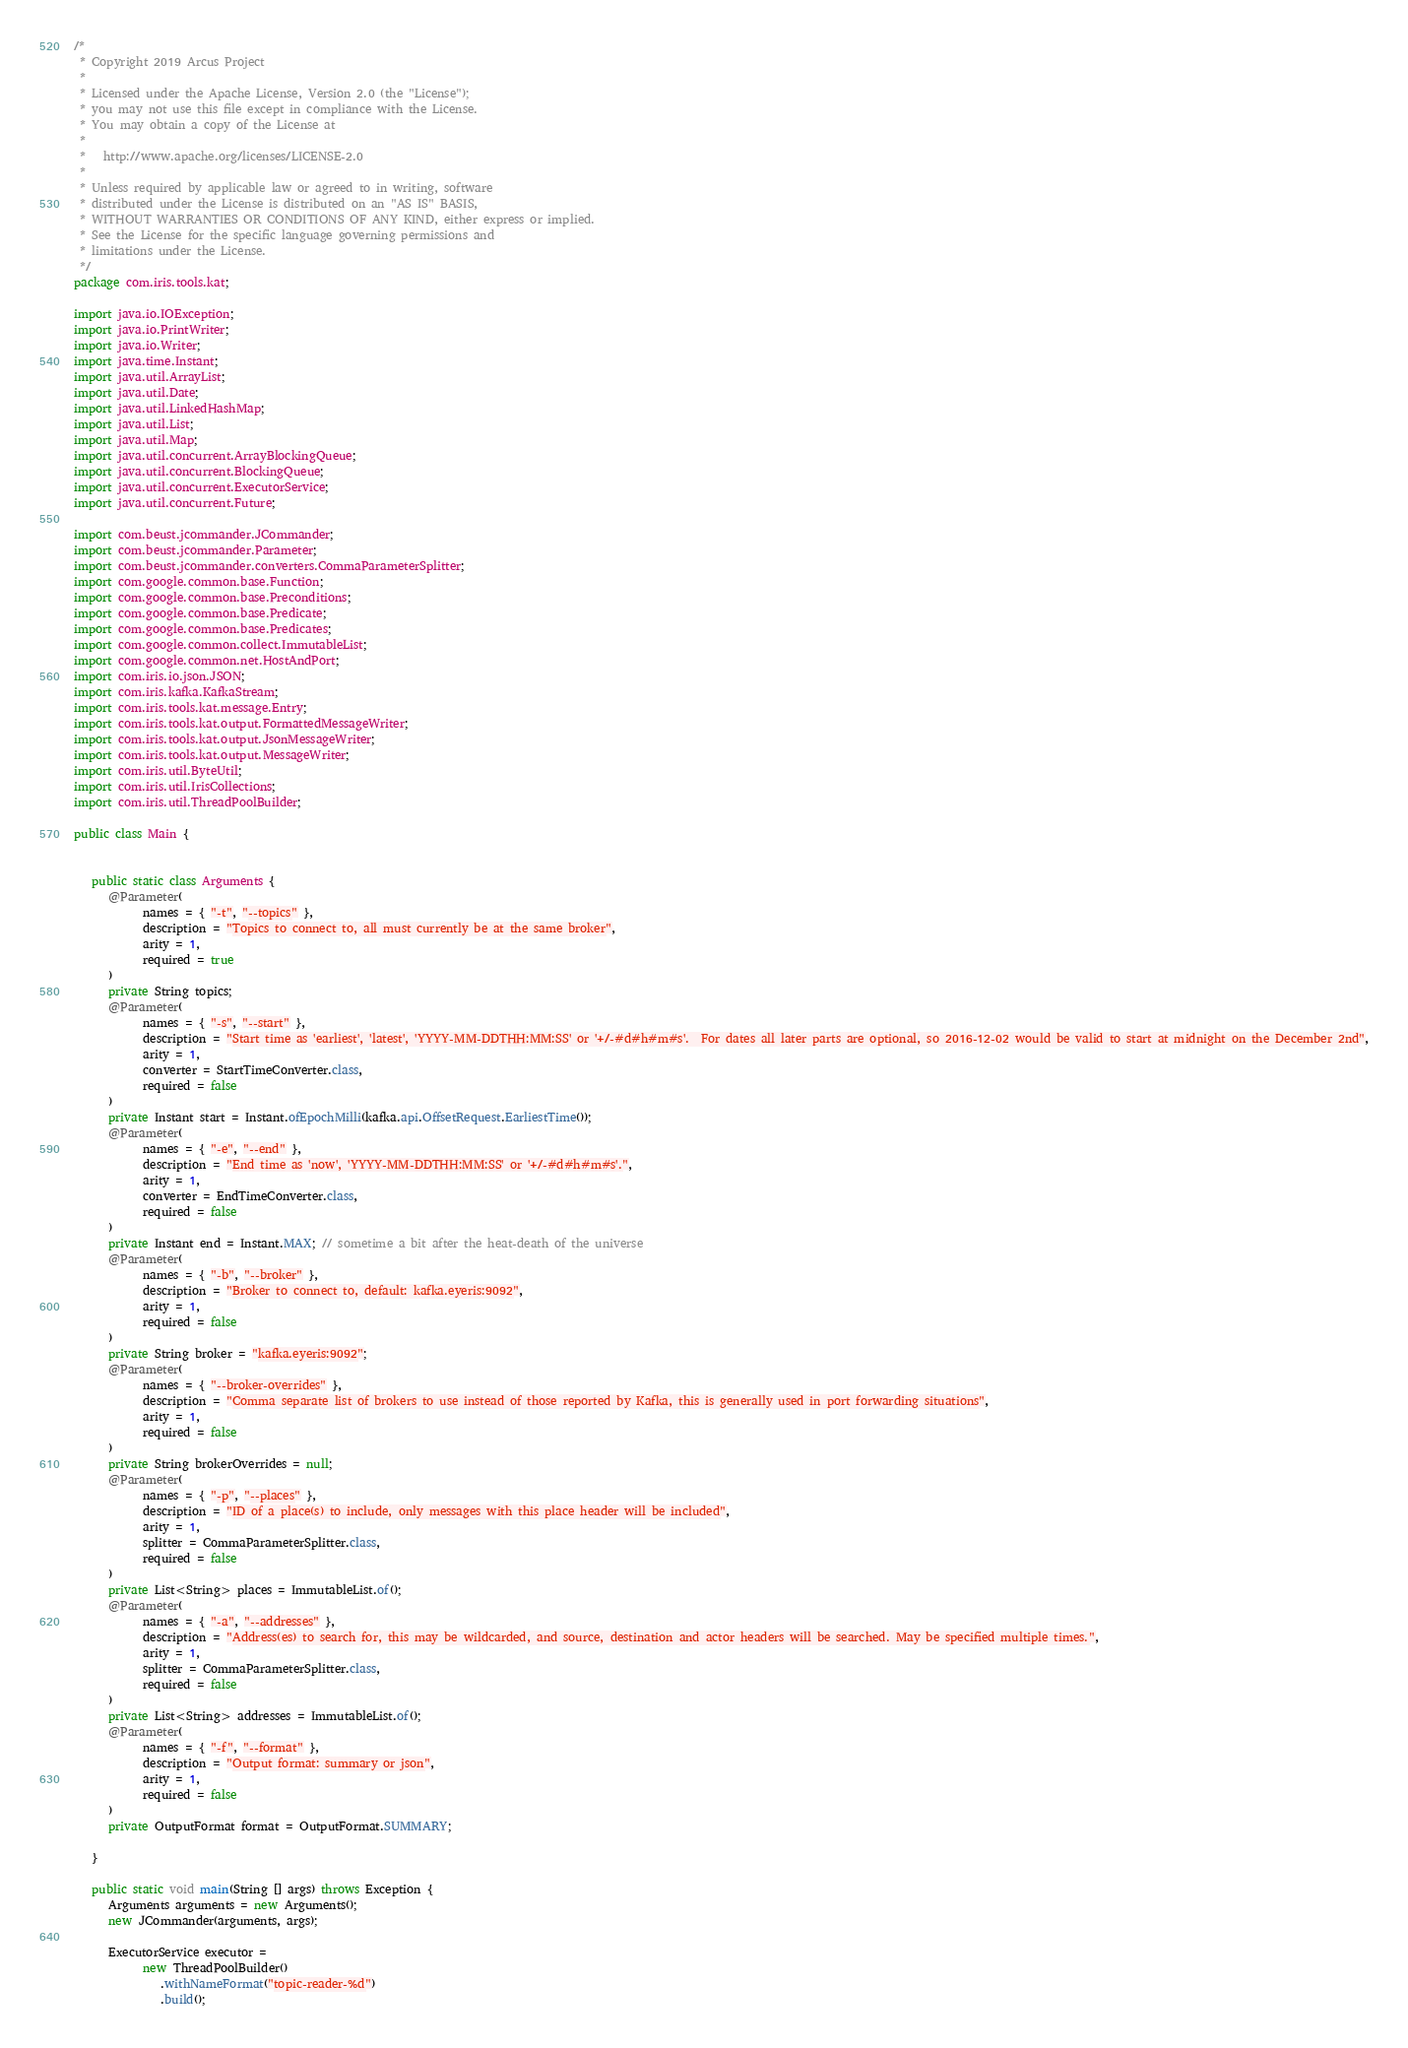<code> <loc_0><loc_0><loc_500><loc_500><_Java_>/*
 * Copyright 2019 Arcus Project
 *
 * Licensed under the Apache License, Version 2.0 (the "License");
 * you may not use this file except in compliance with the License.
 * You may obtain a copy of the License at
 *
 *   http://www.apache.org/licenses/LICENSE-2.0
 *
 * Unless required by applicable law or agreed to in writing, software
 * distributed under the License is distributed on an "AS IS" BASIS,
 * WITHOUT WARRANTIES OR CONDITIONS OF ANY KIND, either express or implied.
 * See the License for the specific language governing permissions and
 * limitations under the License.
 */
package com.iris.tools.kat;

import java.io.IOException;
import java.io.PrintWriter;
import java.io.Writer;
import java.time.Instant;
import java.util.ArrayList;
import java.util.Date;
import java.util.LinkedHashMap;
import java.util.List;
import java.util.Map;
import java.util.concurrent.ArrayBlockingQueue;
import java.util.concurrent.BlockingQueue;
import java.util.concurrent.ExecutorService;
import java.util.concurrent.Future;

import com.beust.jcommander.JCommander;
import com.beust.jcommander.Parameter;
import com.beust.jcommander.converters.CommaParameterSplitter;
import com.google.common.base.Function;
import com.google.common.base.Preconditions;
import com.google.common.base.Predicate;
import com.google.common.base.Predicates;
import com.google.common.collect.ImmutableList;
import com.google.common.net.HostAndPort;
import com.iris.io.json.JSON;
import com.iris.kafka.KafkaStream;
import com.iris.tools.kat.message.Entry;
import com.iris.tools.kat.output.FormattedMessageWriter;
import com.iris.tools.kat.output.JsonMessageWriter;
import com.iris.tools.kat.output.MessageWriter;
import com.iris.util.ByteUtil;
import com.iris.util.IrisCollections;
import com.iris.util.ThreadPoolBuilder;

public class Main {


   public static class Arguments {
      @Parameter(
            names = { "-t", "--topics" },
            description = "Topics to connect to, all must currently be at the same broker",
            arity = 1,
            required = true
      )
      private String topics;
      @Parameter(
            names = { "-s", "--start" },
            description = "Start time as 'earliest', 'latest', 'YYYY-MM-DDTHH:MM:SS' or '+/-#d#h#m#s'.  For dates all later parts are optional, so 2016-12-02 would be valid to start at midnight on the December 2nd",
            arity = 1,
            converter = StartTimeConverter.class,
            required = false
      )
      private Instant start = Instant.ofEpochMilli(kafka.api.OffsetRequest.EarliestTime());
      @Parameter(
            names = { "-e", "--end" },
            description = "End time as 'now', 'YYYY-MM-DDTHH:MM:SS' or '+/-#d#h#m#s'.",
            arity = 1,
            converter = EndTimeConverter.class,
            required = false
      )
      private Instant end = Instant.MAX; // sometime a bit after the heat-death of the universe
      @Parameter(
            names = { "-b", "--broker" },
            description = "Broker to connect to, default: kafka.eyeris:9092",
            arity = 1,
            required = false
      )
      private String broker = "kafka.eyeris:9092";
      @Parameter(
            names = { "--broker-overrides" },
            description = "Comma separate list of brokers to use instead of those reported by Kafka, this is generally used in port forwarding situations",
            arity = 1,
            required = false
      )
      private String brokerOverrides = null;
      @Parameter(
            names = { "-p", "--places" },
            description = "ID of a place(s) to include, only messages with this place header will be included",
            arity = 1,
            splitter = CommaParameterSplitter.class,
            required = false
      )
      private List<String> places = ImmutableList.of();
      @Parameter(
            names = { "-a", "--addresses" },
            description = "Address(es) to search for, this may be wildcarded, and source, destination and actor headers will be searched. May be specified multiple times.",
            arity = 1,
            splitter = CommaParameterSplitter.class,
            required = false
      )
      private List<String> addresses = ImmutableList.of();
      @Parameter(
            names = { "-f", "--format" },
            description = "Output format: summary or json",
            arity = 1,
            required = false
      )
      private OutputFormat format = OutputFormat.SUMMARY;
      
   }

   public static void main(String [] args) throws Exception {
      Arguments arguments = new Arguments();
      new JCommander(arguments, args);
      
      ExecutorService executor =
            new ThreadPoolBuilder()
               .withNameFormat("topic-reader-%d")
               .build();</code> 